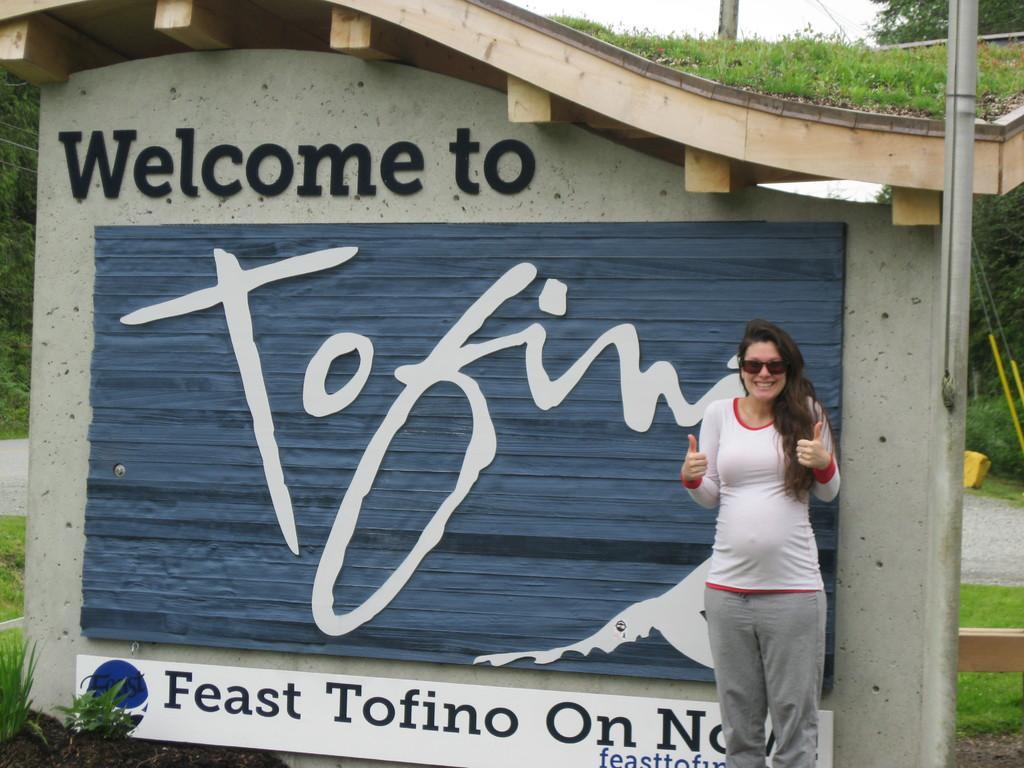Describe this image in one or two sentences. There is a woman in white T-shirt who is wearing goggles is standing and she is smiling. Beside her, we see a pole. Behind her, we see a wall on which blue board is placed. We even see some text written on that wall. At the bottom of the picture, we see grass. There are many trees in the background. 